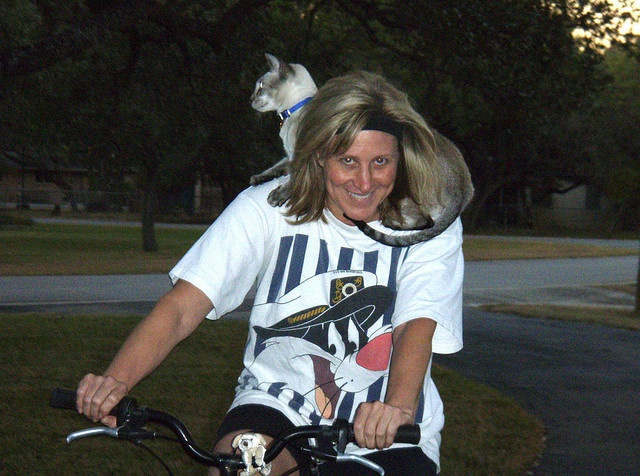Describe the objects in this image and their specific colors. I can see people in black, white, and gray tones, cat in black, gray, darkgray, and darkgreen tones, and bicycle in black, gray, and white tones in this image. 